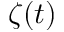Convert formula to latex. <formula><loc_0><loc_0><loc_500><loc_500>\zeta ( t )</formula> 